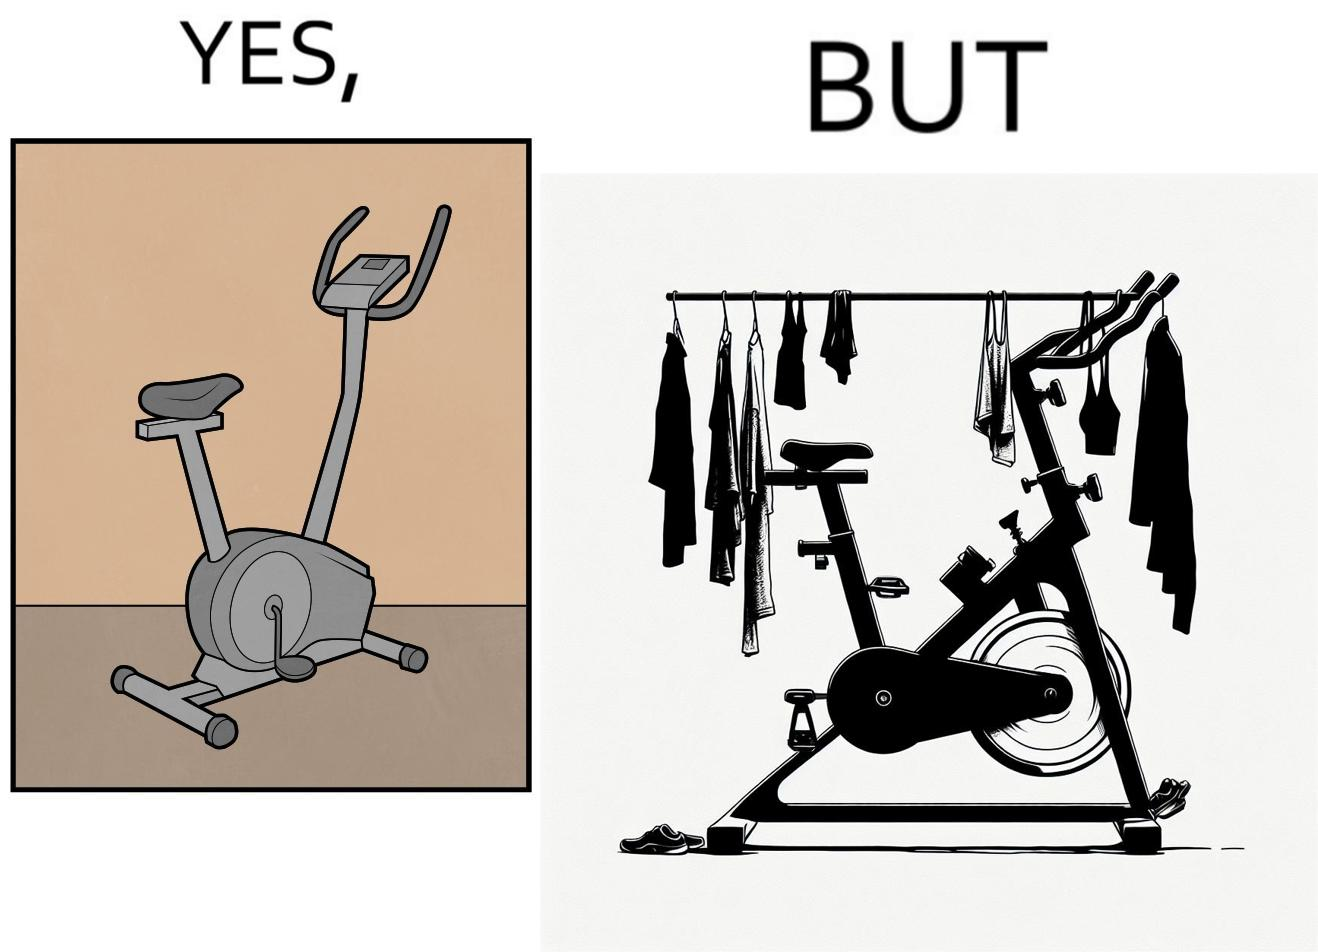What do you see in each half of this image? In the left part of the image: An exercise bike In the right part of the image: An exercise bike being used to hang clothes and other items 